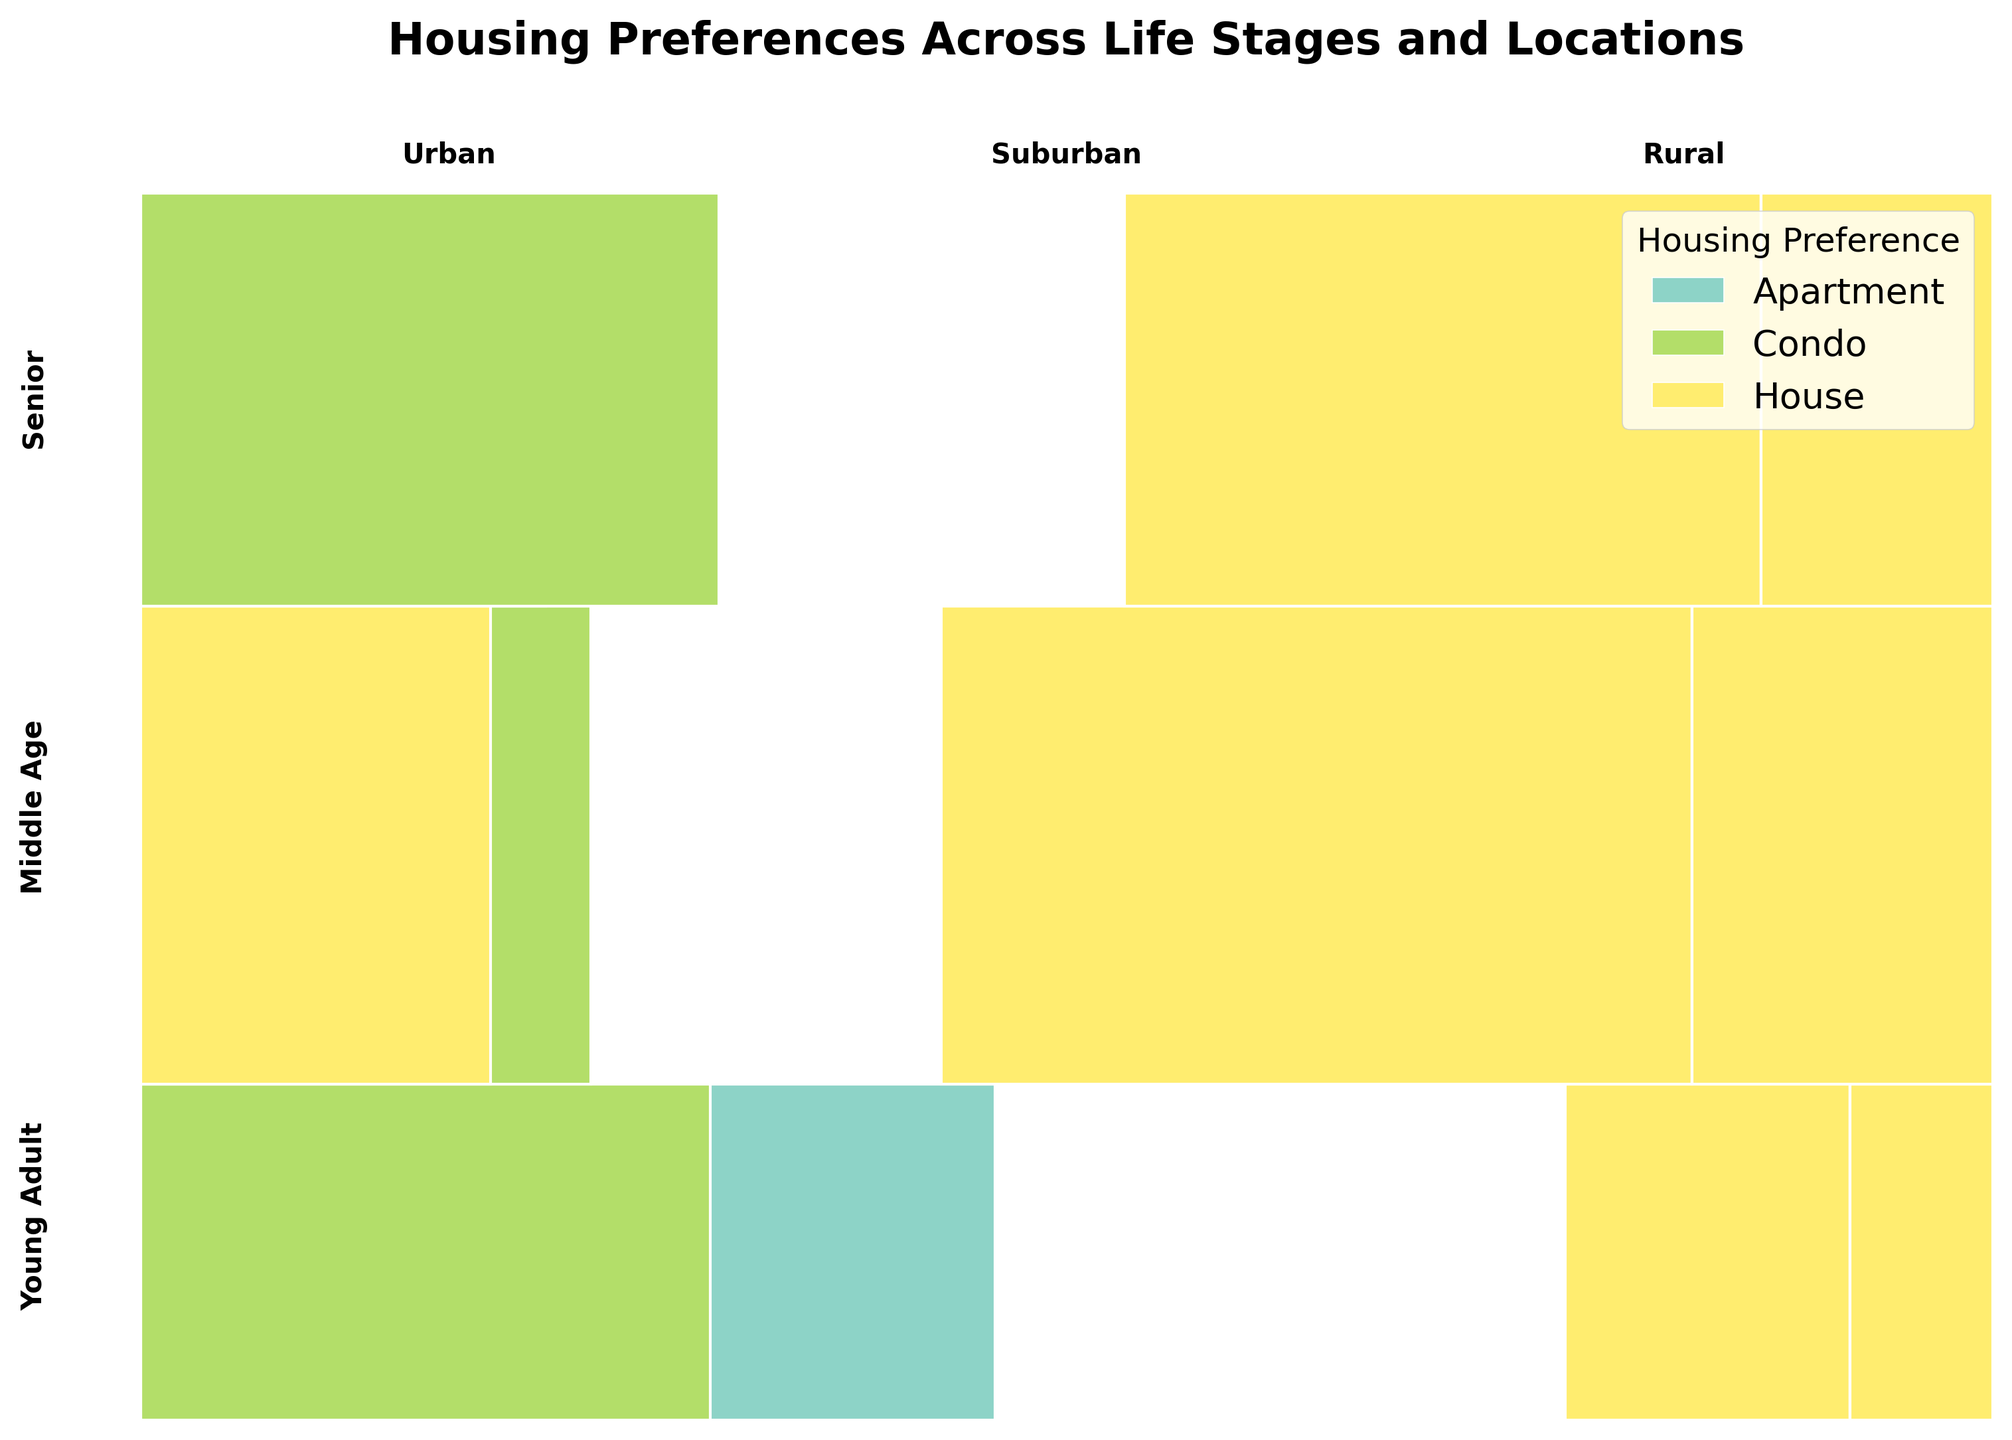What is the title of the figure? The title of the figure can be easily read at the top of the plot.
Answer: Housing Preferences Across Life Stages and Locations Which housing preference is most common among Young Adults in Urban areas? By observing the Urban section in the Young Adult row, we can compare the rectangle sizes. The largest section corresponds to Apartments.
Answer: Apartment In which location and life stage is the preference for Houses the highest? We need to look at each location and life stage combination, and identify where the area representing Houses is the largest. Middle Age in Suburban areas has the largest section for Houses.
Answer: Middle Age, Suburban Is there any life stage/location combination where the preference for Apartments does not appear at all? By examining each section of the mosaic plot, we notice that Apartments do not appear in Middle Age (Suburban and Rural) and Senior (Suburban and Rural) locations.
Answer: Yes How does the preference for Condos in Urban areas change between Young Adults and Seniors? Compare the size of the Condos section in the Urban area for Young Adults and Seniors. For Young Adults, the Condo section is smaller, while for Seniors it is larger.
Answer: It increases Is the preference for Houses consistent across different life stages in Suburban locations? In the Suburban section, we look at the size of the House rectangles for different life stages. It shows a substantial preference throughout, with Middle Age having the largest rectangle.
Answer: Yes Which life stage has the least preference for Apartments? Observe the three rows representing different life stages and compare the Apartment sections' sizes. Seniors have the smallest section for Apartments.
Answer: Senior Does the dominance of any housing preference change with the shift from Urban to Rural areas for Middle Age individuals? In the Middle Age section, compare Urban and Rural preferences. In Urban, Condos are preferred, while in Rural, Houses dominate.
Answer: Yes Is there any housing preference that completely dominates in any life stage/location combination? Check for any sections where only one type of housing occupies the entire space. In Middle Age, Rural areas, Houses completely dominate.
Answer: Yes, Houses in Middle Age, Rural How does the housing preference for Condos in Suburban areas compare between Young Adults and Seniors? In the Suburban area, compare the size of the Condo sections for Young Adults and Seniors. Neither Young Adults nor Seniors show a preference for Condos in Suburban areas.
Answer: Similar (non-preference) 